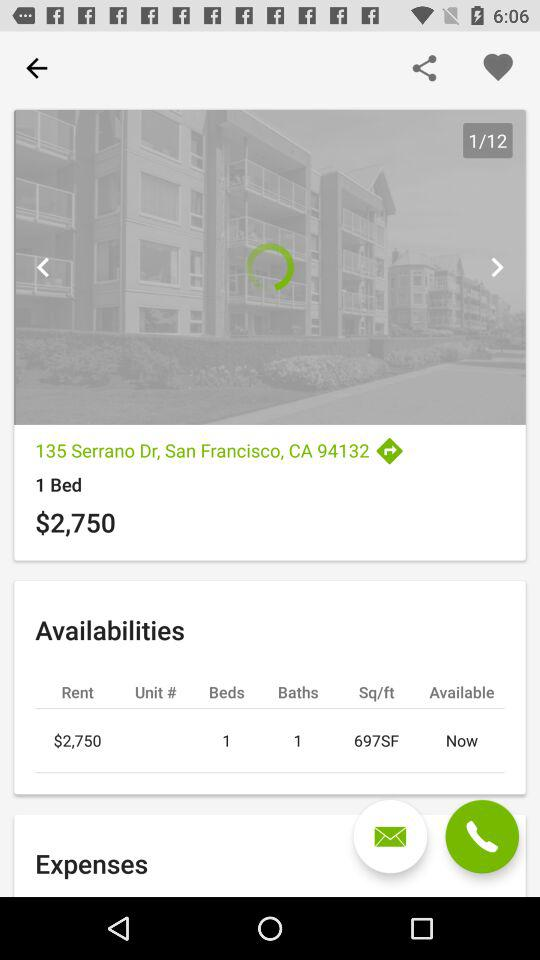How many beds are there? There is 1 bed. 